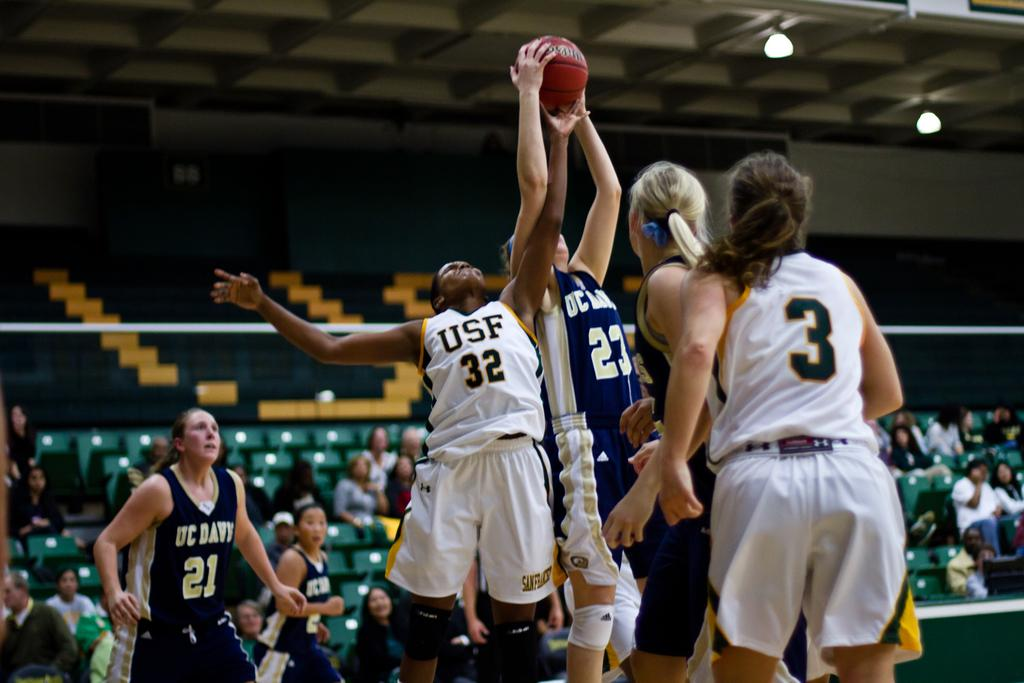<image>
Render a clear and concise summary of the photo. A women's basketball game between USF and UC Davis. 